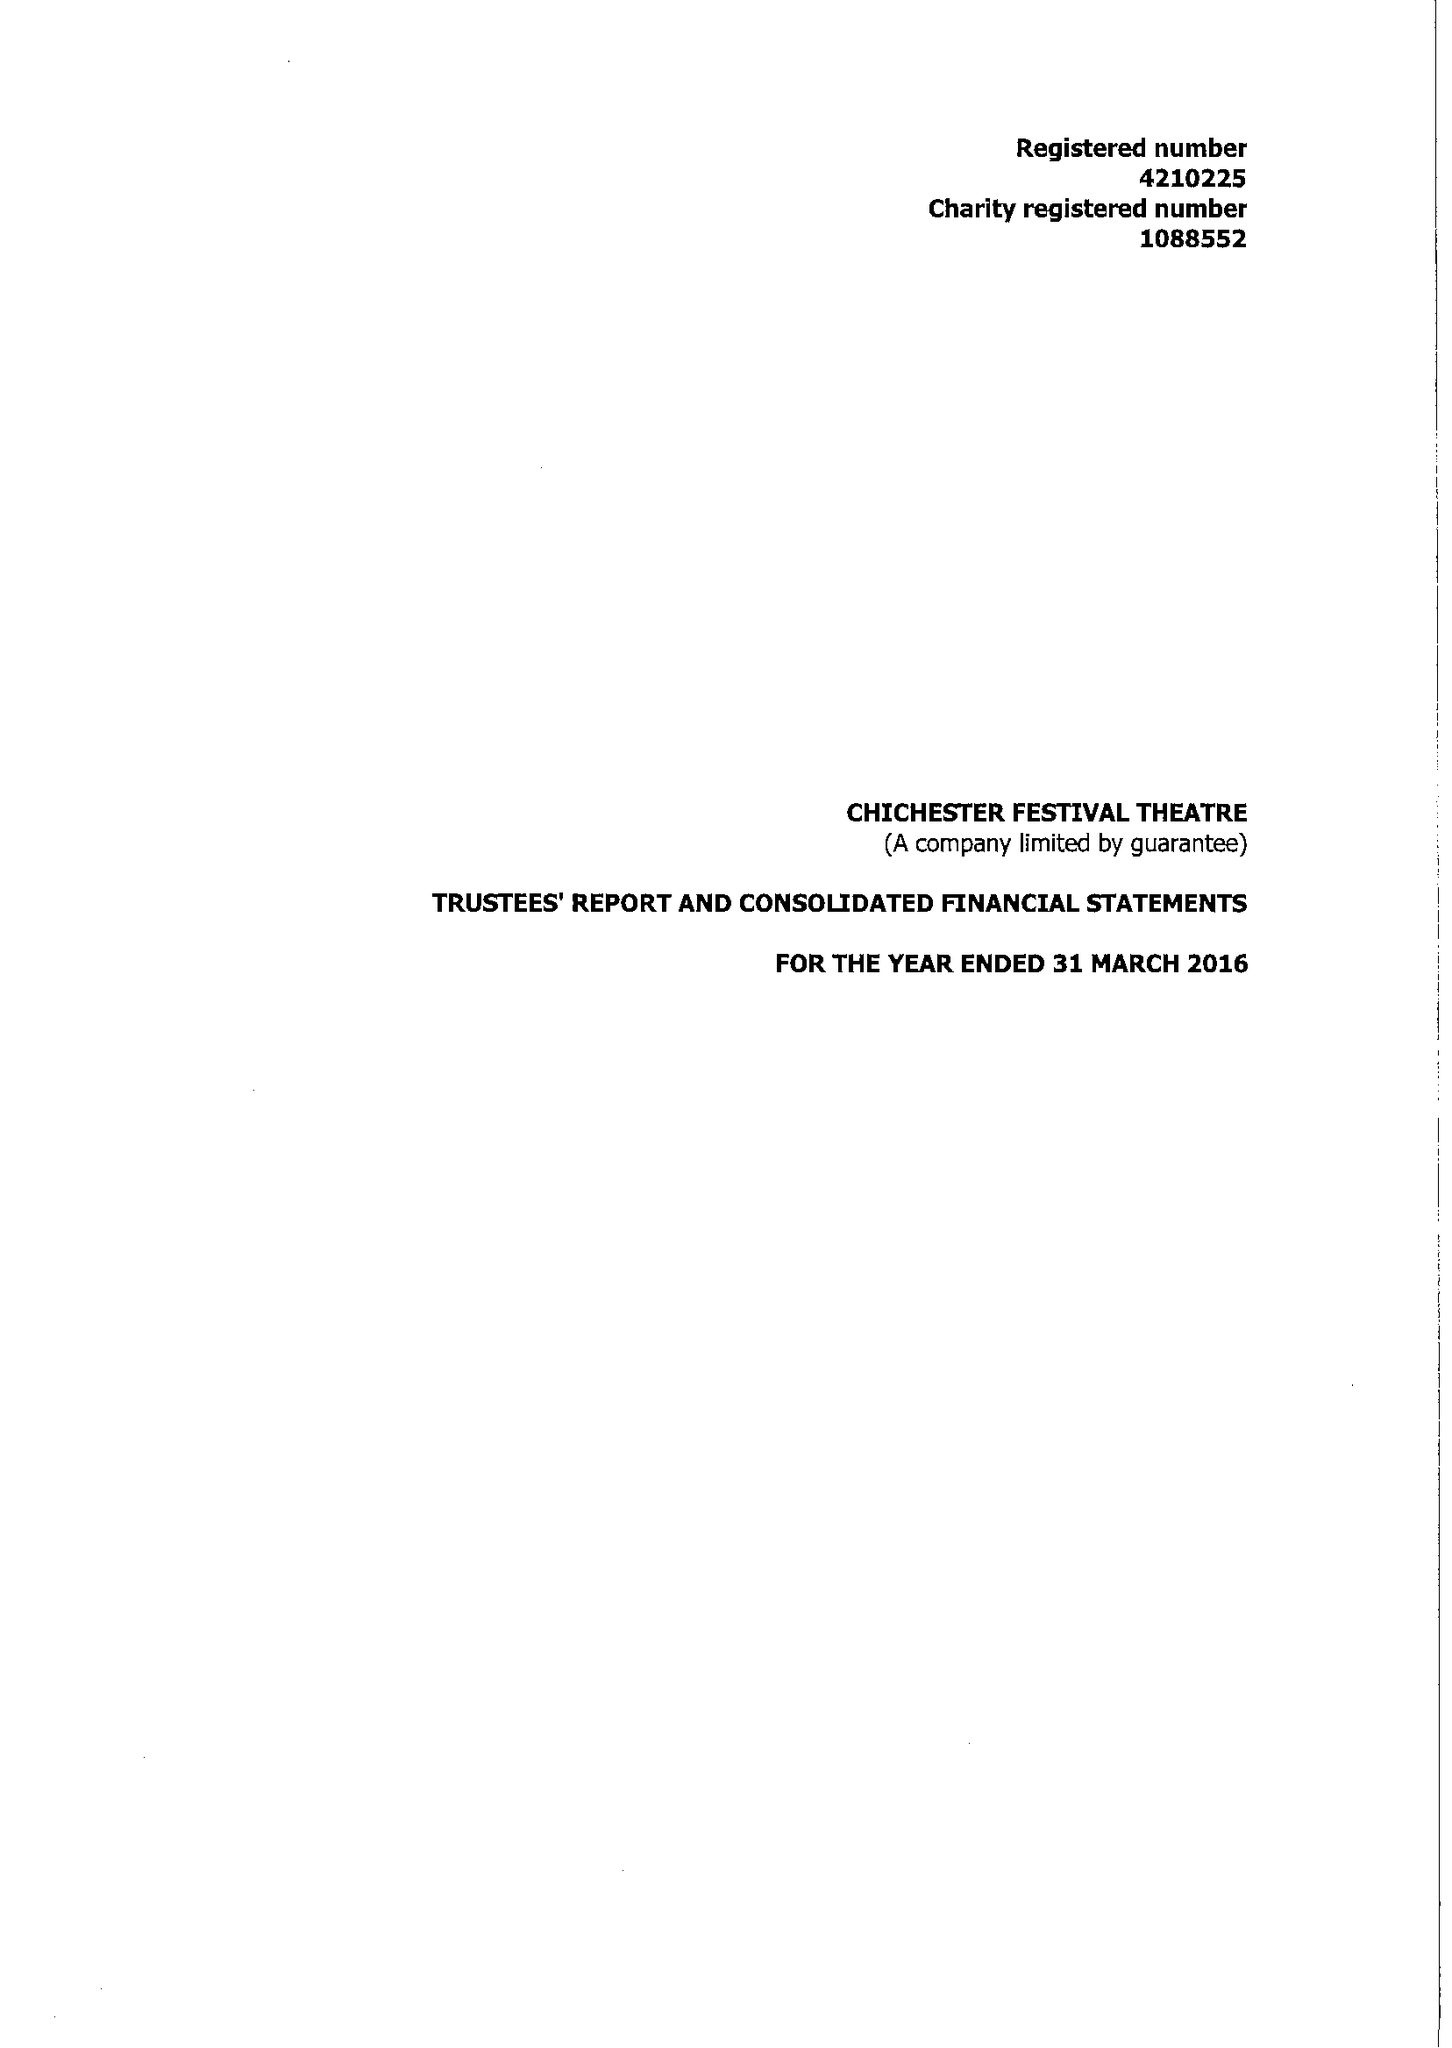What is the value for the charity_number?
Answer the question using a single word or phrase. 1088552 